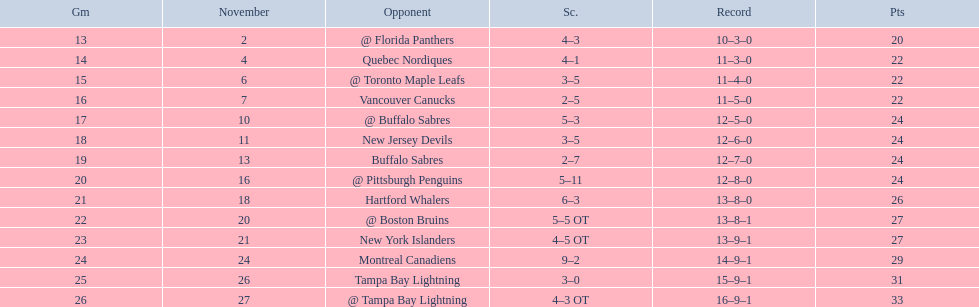What was the number of wins the philadelphia flyers had? 35. 